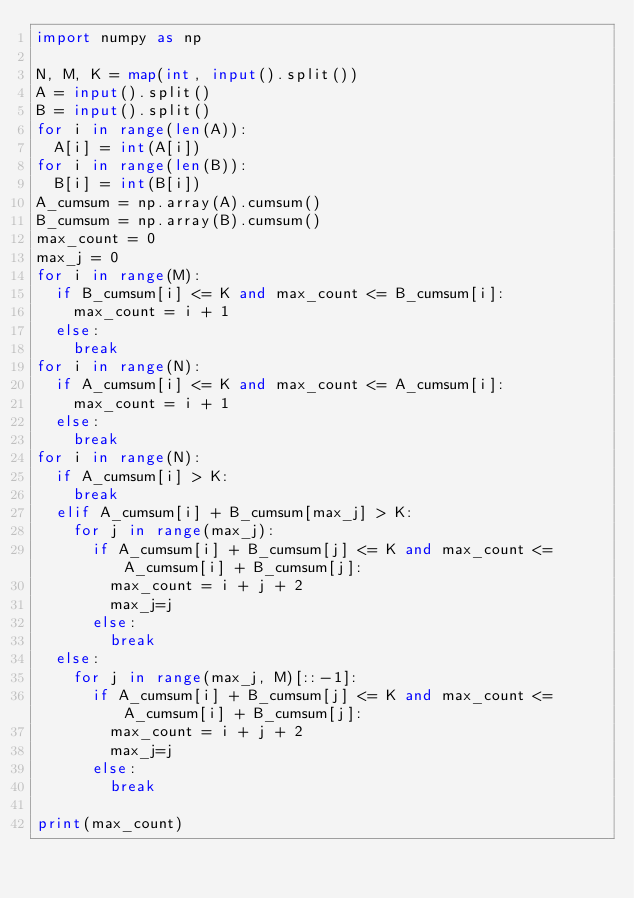<code> <loc_0><loc_0><loc_500><loc_500><_Python_>import numpy as np

N, M, K = map(int, input().split())
A = input().split()
B = input().split()
for i in range(len(A)):
  A[i] = int(A[i])
for i in range(len(B)):
  B[i] = int(B[i])
A_cumsum = np.array(A).cumsum()
B_cumsum = np.array(B).cumsum()
max_count = 0
max_j = 0
for i in range(M):
  if B_cumsum[i] <= K and max_count <= B_cumsum[i]:
    max_count = i + 1
  else:
    break
for i in range(N):
  if A_cumsum[i] <= K and max_count <= A_cumsum[i]:
    max_count = i + 1
  else:
    break
for i in range(N):
  if A_cumsum[i] > K:
    break
  elif A_cumsum[i] + B_cumsum[max_j] > K:
    for j in range(max_j):
      if A_cumsum[i] + B_cumsum[j] <= K and max_count <= A_cumsum[i] + B_cumsum[j]:
        max_count = i + j + 2
        max_j=j
      else:
        break
  else:
    for j in range(max_j, M)[::-1]:
      if A_cumsum[i] + B_cumsum[j] <= K and max_count <= A_cumsum[i] + B_cumsum[j]:
        max_count = i + j + 2
        max_j=j
      else:
        break
    
print(max_count)</code> 